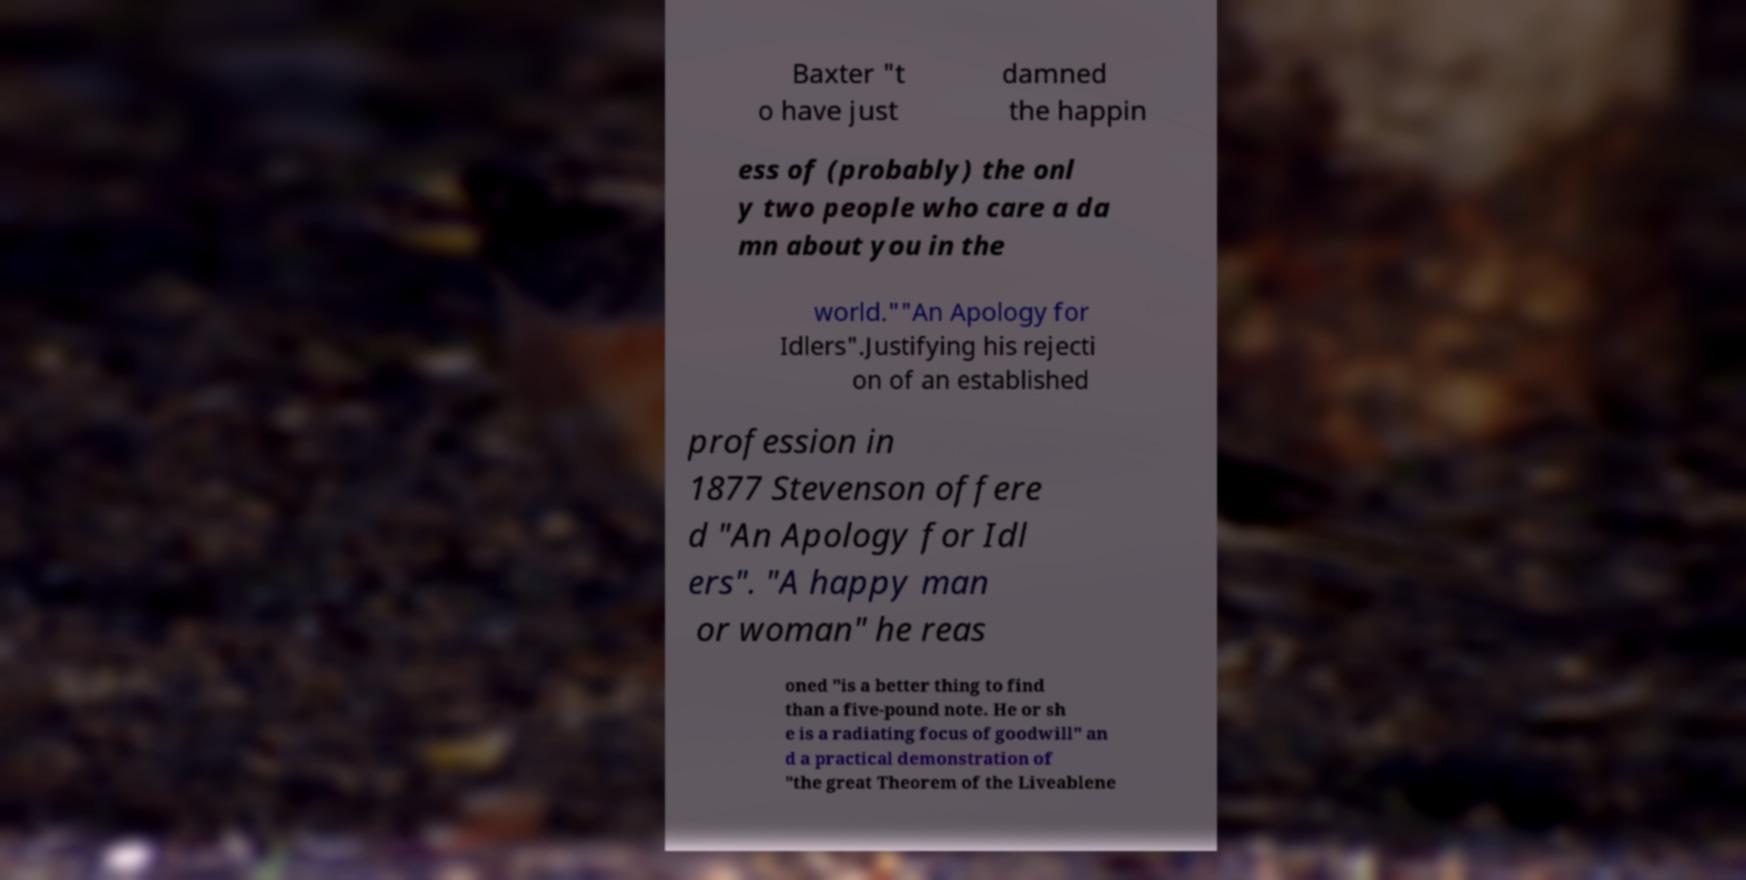Could you assist in decoding the text presented in this image and type it out clearly? Baxter "t o have just damned the happin ess of (probably) the onl y two people who care a da mn about you in the world.""An Apology for Idlers".Justifying his rejecti on of an established profession in 1877 Stevenson offere d "An Apology for Idl ers". "A happy man or woman" he reas oned "is a better thing to find than a five-pound note. He or sh e is a radiating focus of goodwill" an d a practical demonstration of "the great Theorem of the Liveablene 